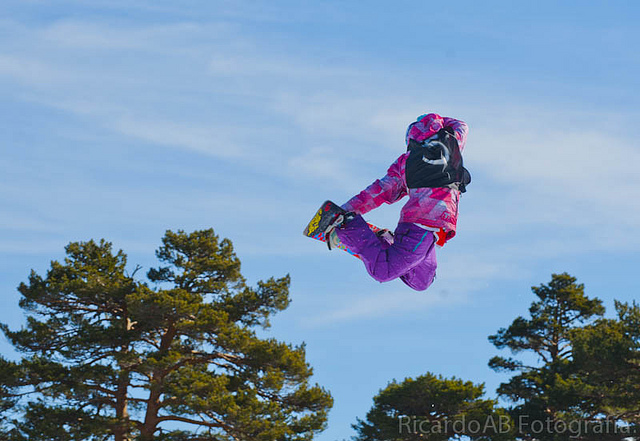<image>What is the man of the tree on the left? I don't know what the man of the tree on the left is. The responses are ambiguous. What is the man of the tree on the left? I don't know what the man on the tree on the left is. It can be seen as a kite, snowboard, lumberjack, skating, surfboard, in air, pine, or skydiver. 